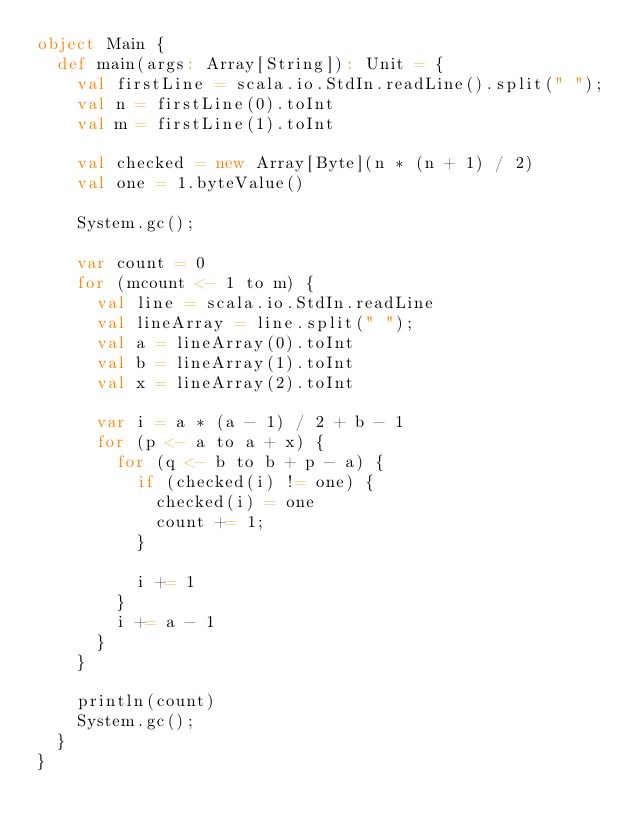<code> <loc_0><loc_0><loc_500><loc_500><_Scala_>object Main {
  def main(args: Array[String]): Unit = {
    val firstLine = scala.io.StdIn.readLine().split(" ");
    val n = firstLine(0).toInt
    val m = firstLine(1).toInt

    val checked = new Array[Byte](n * (n + 1) / 2)
    val one = 1.byteValue()

    System.gc();

    var count = 0
    for (mcount <- 1 to m) {
      val line = scala.io.StdIn.readLine
      val lineArray = line.split(" ");
      val a = lineArray(0).toInt
      val b = lineArray(1).toInt
      val x = lineArray(2).toInt

      var i = a * (a - 1) / 2 + b - 1
      for (p <- a to a + x) {
        for (q <- b to b + p - a) {
          if (checked(i) != one) {
            checked(i) = one
            count += 1;
          }

          i += 1
        }
        i += a - 1
      }
    }

    println(count)
    System.gc();
  }
}</code> 